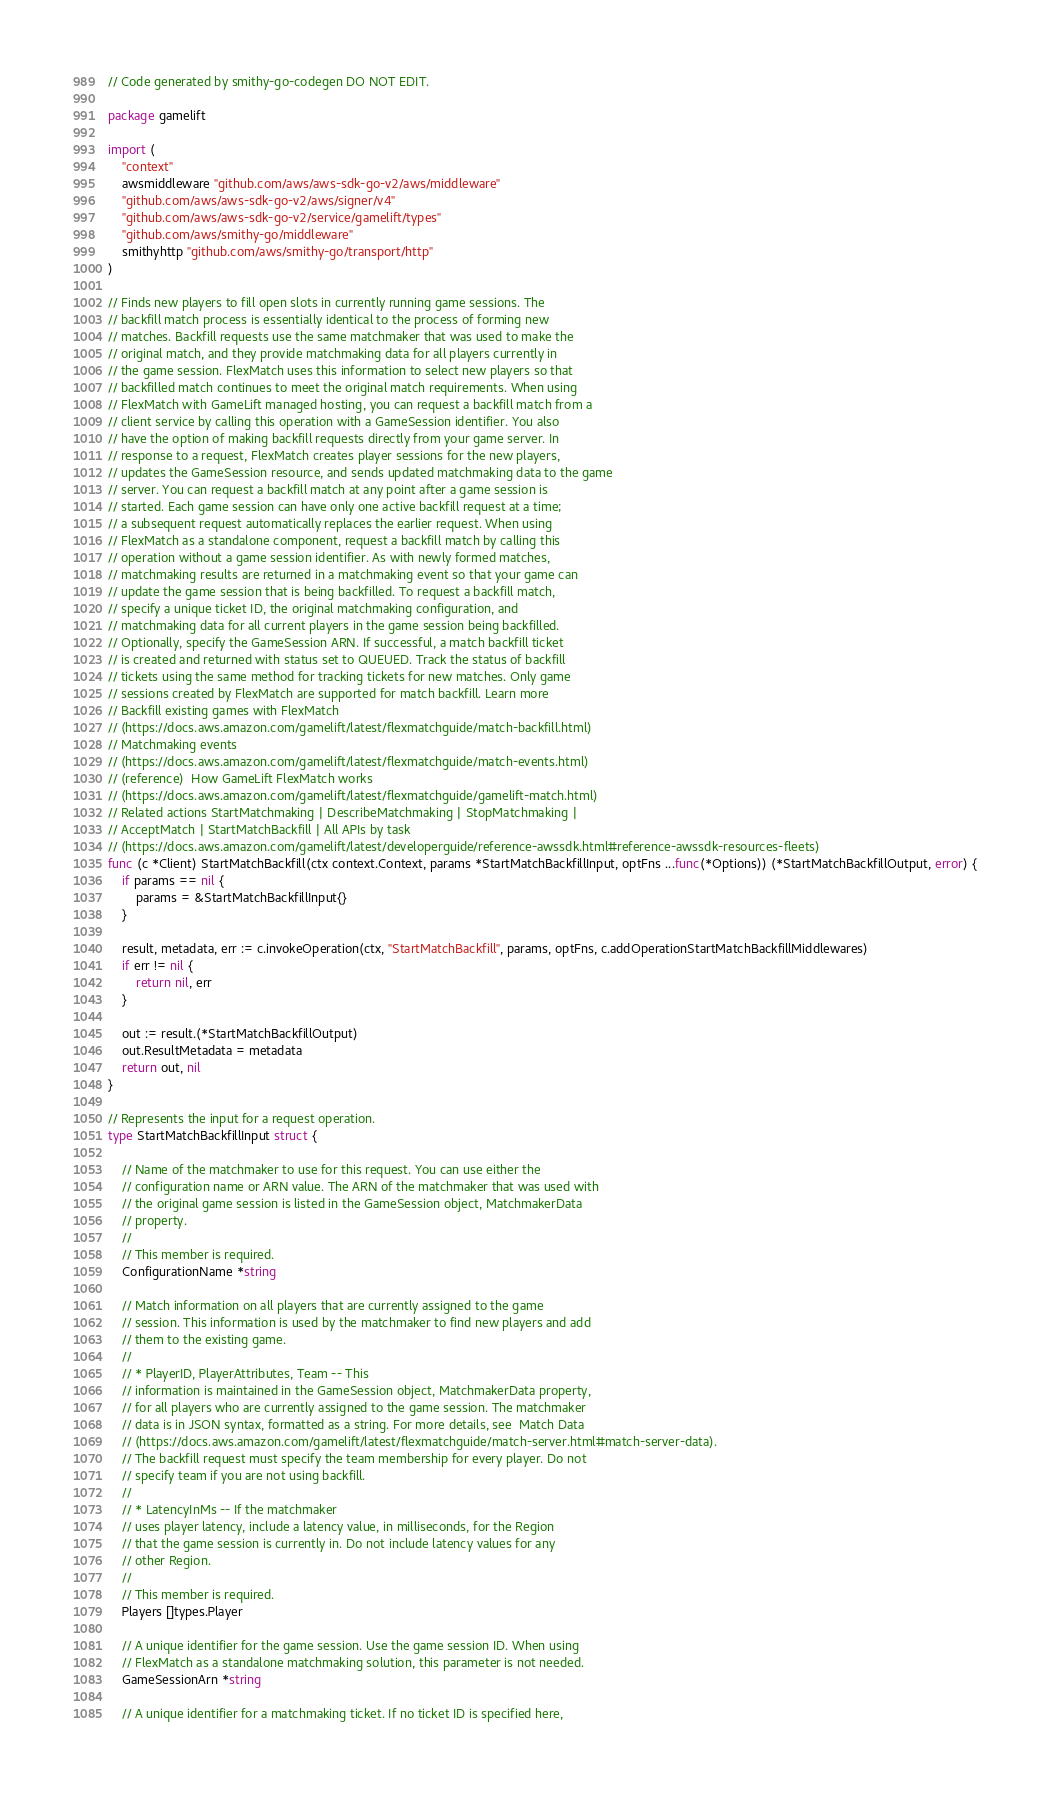Convert code to text. <code><loc_0><loc_0><loc_500><loc_500><_Go_>// Code generated by smithy-go-codegen DO NOT EDIT.

package gamelift

import (
	"context"
	awsmiddleware "github.com/aws/aws-sdk-go-v2/aws/middleware"
	"github.com/aws/aws-sdk-go-v2/aws/signer/v4"
	"github.com/aws/aws-sdk-go-v2/service/gamelift/types"
	"github.com/aws/smithy-go/middleware"
	smithyhttp "github.com/aws/smithy-go/transport/http"
)

// Finds new players to fill open slots in currently running game sessions. The
// backfill match process is essentially identical to the process of forming new
// matches. Backfill requests use the same matchmaker that was used to make the
// original match, and they provide matchmaking data for all players currently in
// the game session. FlexMatch uses this information to select new players so that
// backfilled match continues to meet the original match requirements. When using
// FlexMatch with GameLift managed hosting, you can request a backfill match from a
// client service by calling this operation with a GameSession identifier. You also
// have the option of making backfill requests directly from your game server. In
// response to a request, FlexMatch creates player sessions for the new players,
// updates the GameSession resource, and sends updated matchmaking data to the game
// server. You can request a backfill match at any point after a game session is
// started. Each game session can have only one active backfill request at a time;
// a subsequent request automatically replaces the earlier request. When using
// FlexMatch as a standalone component, request a backfill match by calling this
// operation without a game session identifier. As with newly formed matches,
// matchmaking results are returned in a matchmaking event so that your game can
// update the game session that is being backfilled. To request a backfill match,
// specify a unique ticket ID, the original matchmaking configuration, and
// matchmaking data for all current players in the game session being backfilled.
// Optionally, specify the GameSession ARN. If successful, a match backfill ticket
// is created and returned with status set to QUEUED. Track the status of backfill
// tickets using the same method for tracking tickets for new matches. Only game
// sessions created by FlexMatch are supported for match backfill. Learn more
// Backfill existing games with FlexMatch
// (https://docs.aws.amazon.com/gamelift/latest/flexmatchguide/match-backfill.html)
// Matchmaking events
// (https://docs.aws.amazon.com/gamelift/latest/flexmatchguide/match-events.html)
// (reference)  How GameLift FlexMatch works
// (https://docs.aws.amazon.com/gamelift/latest/flexmatchguide/gamelift-match.html)
// Related actions StartMatchmaking | DescribeMatchmaking | StopMatchmaking |
// AcceptMatch | StartMatchBackfill | All APIs by task
// (https://docs.aws.amazon.com/gamelift/latest/developerguide/reference-awssdk.html#reference-awssdk-resources-fleets)
func (c *Client) StartMatchBackfill(ctx context.Context, params *StartMatchBackfillInput, optFns ...func(*Options)) (*StartMatchBackfillOutput, error) {
	if params == nil {
		params = &StartMatchBackfillInput{}
	}

	result, metadata, err := c.invokeOperation(ctx, "StartMatchBackfill", params, optFns, c.addOperationStartMatchBackfillMiddlewares)
	if err != nil {
		return nil, err
	}

	out := result.(*StartMatchBackfillOutput)
	out.ResultMetadata = metadata
	return out, nil
}

// Represents the input for a request operation.
type StartMatchBackfillInput struct {

	// Name of the matchmaker to use for this request. You can use either the
	// configuration name or ARN value. The ARN of the matchmaker that was used with
	// the original game session is listed in the GameSession object, MatchmakerData
	// property.
	//
	// This member is required.
	ConfigurationName *string

	// Match information on all players that are currently assigned to the game
	// session. This information is used by the matchmaker to find new players and add
	// them to the existing game.
	//
	// * PlayerID, PlayerAttributes, Team -- This
	// information is maintained in the GameSession object, MatchmakerData property,
	// for all players who are currently assigned to the game session. The matchmaker
	// data is in JSON syntax, formatted as a string. For more details, see  Match Data
	// (https://docs.aws.amazon.com/gamelift/latest/flexmatchguide/match-server.html#match-server-data).
	// The backfill request must specify the team membership for every player. Do not
	// specify team if you are not using backfill.
	//
	// * LatencyInMs -- If the matchmaker
	// uses player latency, include a latency value, in milliseconds, for the Region
	// that the game session is currently in. Do not include latency values for any
	// other Region.
	//
	// This member is required.
	Players []types.Player

	// A unique identifier for the game session. Use the game session ID. When using
	// FlexMatch as a standalone matchmaking solution, this parameter is not needed.
	GameSessionArn *string

	// A unique identifier for a matchmaking ticket. If no ticket ID is specified here,</code> 